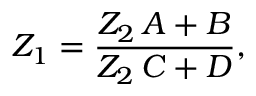<formula> <loc_0><loc_0><loc_500><loc_500>Z _ { 1 } = \frac { Z _ { 2 } \, A + B } { Z _ { 2 } \, C + D } ,</formula> 